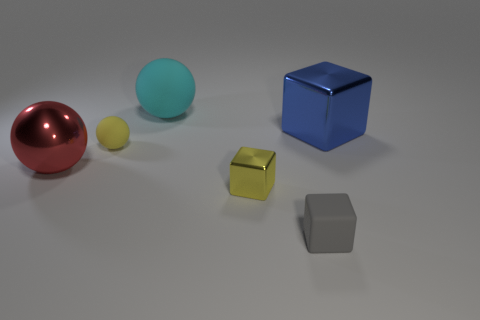What number of gray matte objects are right of the metallic block that is left of the metal block right of the tiny shiny thing?
Give a very brief answer. 1. There is a gray rubber block; is its size the same as the metal thing left of the large cyan matte sphere?
Provide a succinct answer. No. How many tiny green matte cylinders are there?
Ensure brevity in your answer.  0. Does the matte thing behind the blue metallic block have the same size as the block on the left side of the gray thing?
Your answer should be very brief. No. There is another large thing that is the same shape as the large red thing; what color is it?
Your response must be concise. Cyan. Is the shape of the tiny yellow metallic object the same as the big cyan object?
Offer a very short reply. No. The cyan matte thing that is the same shape as the red thing is what size?
Provide a succinct answer. Large. How many big things have the same material as the tiny ball?
Your response must be concise. 1. What number of objects are either small rubber objects or red shiny spheres?
Your response must be concise. 3. There is a gray object in front of the small yellow metal block; is there a large shiny object that is on the right side of it?
Offer a very short reply. Yes. 